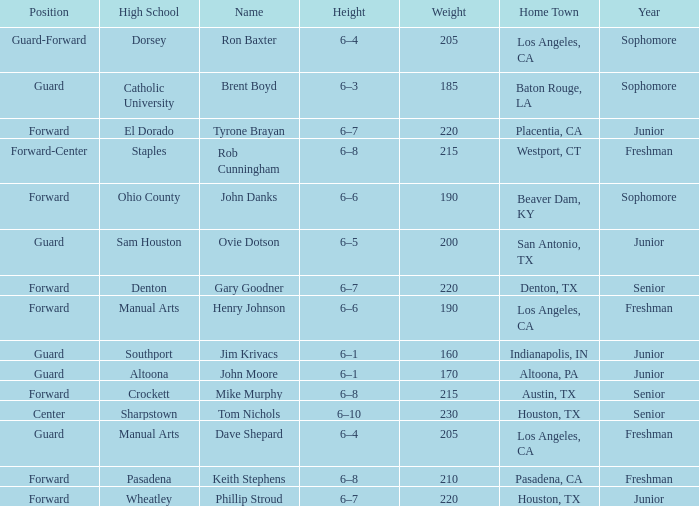What is the Name with a Year of junior, and a High School with wheatley? Phillip Stroud. 